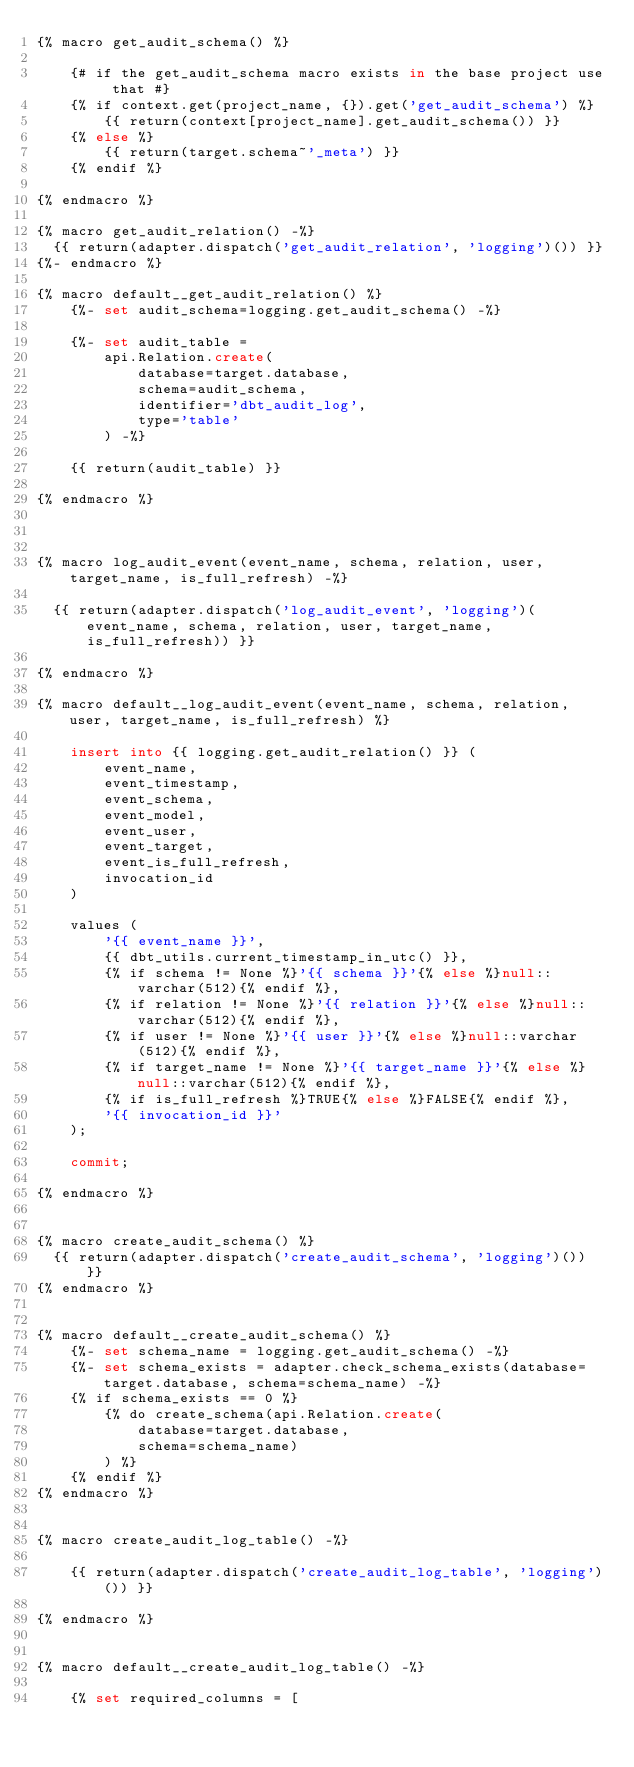Convert code to text. <code><loc_0><loc_0><loc_500><loc_500><_SQL_>{% macro get_audit_schema() %}

    {# if the get_audit_schema macro exists in the base project use that #}
    {% if context.get(project_name, {}).get('get_audit_schema') %}
        {{ return(context[project_name].get_audit_schema()) }}
    {% else %}
        {{ return(target.schema~'_meta') }}
    {% endif %}

{% endmacro %}

{% macro get_audit_relation() -%}
  {{ return(adapter.dispatch('get_audit_relation', 'logging')()) }}
{%- endmacro %}

{% macro default__get_audit_relation() %}
    {%- set audit_schema=logging.get_audit_schema() -%}

    {%- set audit_table =
        api.Relation.create(
            database=target.database,
            schema=audit_schema,
            identifier='dbt_audit_log',
            type='table'
        ) -%}

    {{ return(audit_table) }}

{% endmacro %}



{% macro log_audit_event(event_name, schema, relation, user, target_name, is_full_refresh) -%}

  {{ return(adapter.dispatch('log_audit_event', 'logging')(event_name, schema, relation, user, target_name, is_full_refresh)) }}

{% endmacro %}

{% macro default__log_audit_event(event_name, schema, relation, user, target_name, is_full_refresh) %}

    insert into {{ logging.get_audit_relation() }} (
        event_name,
        event_timestamp,
        event_schema,
        event_model,
        event_user,
        event_target,
        event_is_full_refresh,
        invocation_id
    )

    values (
        '{{ event_name }}',
        {{ dbt_utils.current_timestamp_in_utc() }},
        {% if schema != None %}'{{ schema }}'{% else %}null::varchar(512){% endif %},
        {% if relation != None %}'{{ relation }}'{% else %}null::varchar(512){% endif %},
        {% if user != None %}'{{ user }}'{% else %}null::varchar(512){% endif %},
        {% if target_name != None %}'{{ target_name }}'{% else %}null::varchar(512){% endif %},
        {% if is_full_refresh %}TRUE{% else %}FALSE{% endif %},
        '{{ invocation_id }}'
    );

    commit;

{% endmacro %}


{% macro create_audit_schema() %}
  {{ return(adapter.dispatch('create_audit_schema', 'logging')()) }}
{% endmacro %}


{% macro default__create_audit_schema() %}
    {%- set schema_name = logging.get_audit_schema() -%}
    {%- set schema_exists = adapter.check_schema_exists(database=target.database, schema=schema_name) -%}
    {% if schema_exists == 0 %}
        {% do create_schema(api.Relation.create(
            database=target.database,
            schema=schema_name)
        ) %}
    {% endif %}
{% endmacro %}


{% macro create_audit_log_table() -%}

    {{ return(adapter.dispatch('create_audit_log_table', 'logging')()) }}

{% endmacro %}


{% macro default__create_audit_log_table() -%}

    {% set required_columns = [</code> 